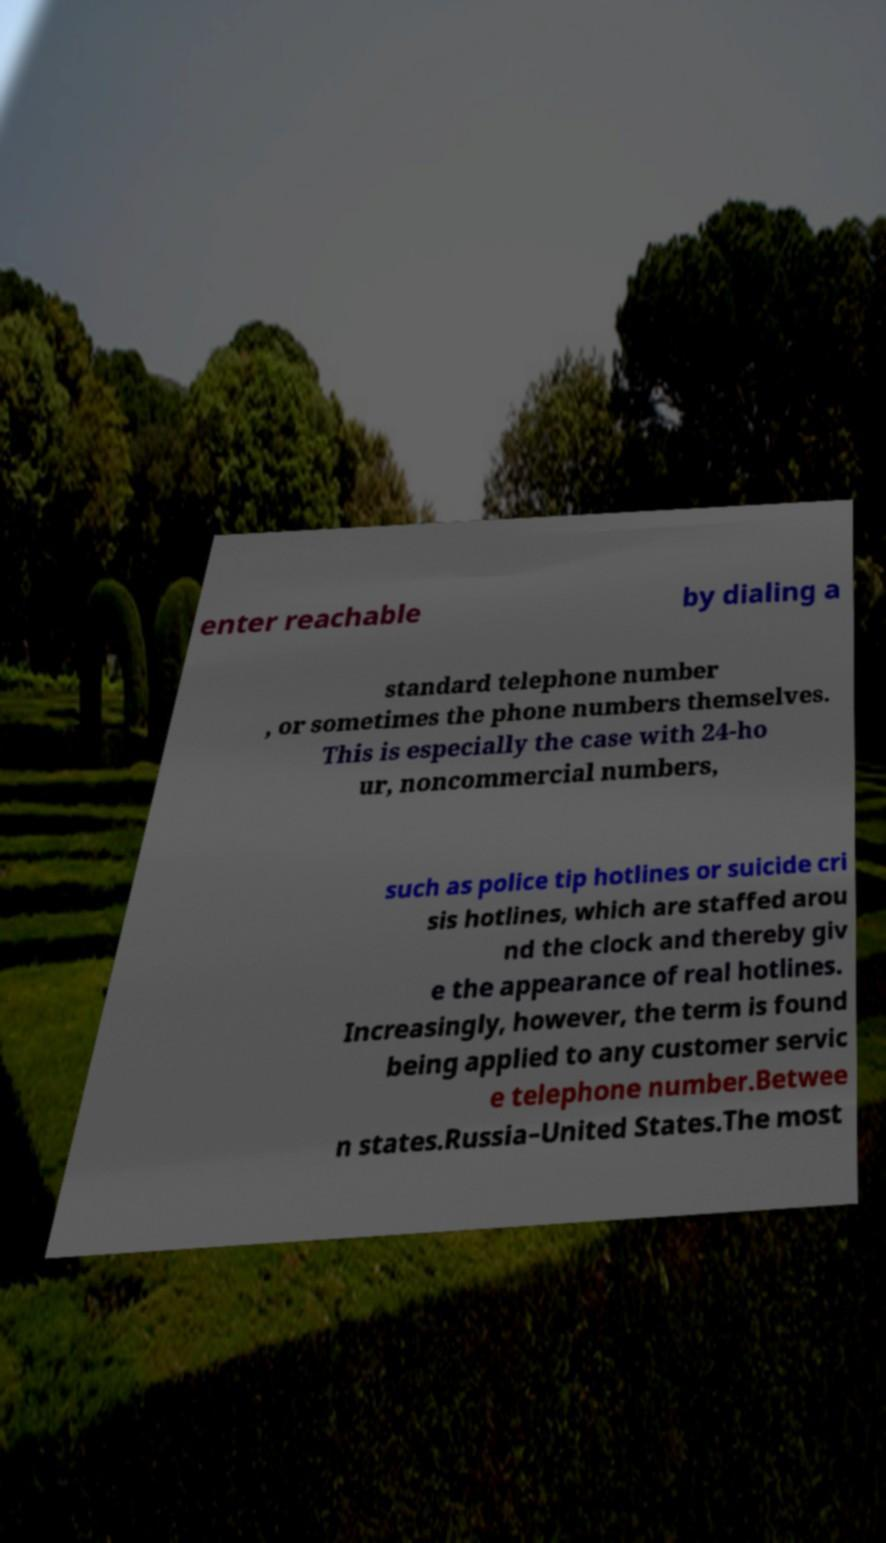Can you read and provide the text displayed in the image?This photo seems to have some interesting text. Can you extract and type it out for me? enter reachable by dialing a standard telephone number , or sometimes the phone numbers themselves. This is especially the case with 24-ho ur, noncommercial numbers, such as police tip hotlines or suicide cri sis hotlines, which are staffed arou nd the clock and thereby giv e the appearance of real hotlines. Increasingly, however, the term is found being applied to any customer servic e telephone number.Betwee n states.Russia–United States.The most 